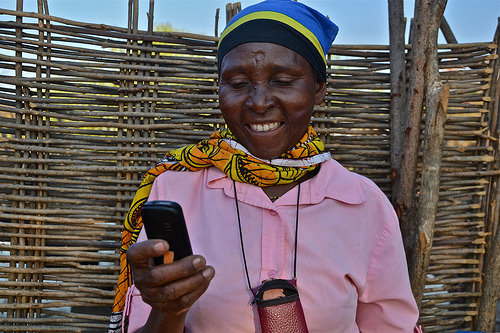<image>
Is there a pouch in front of the lady? Yes. The pouch is positioned in front of the lady, appearing closer to the camera viewpoint. 